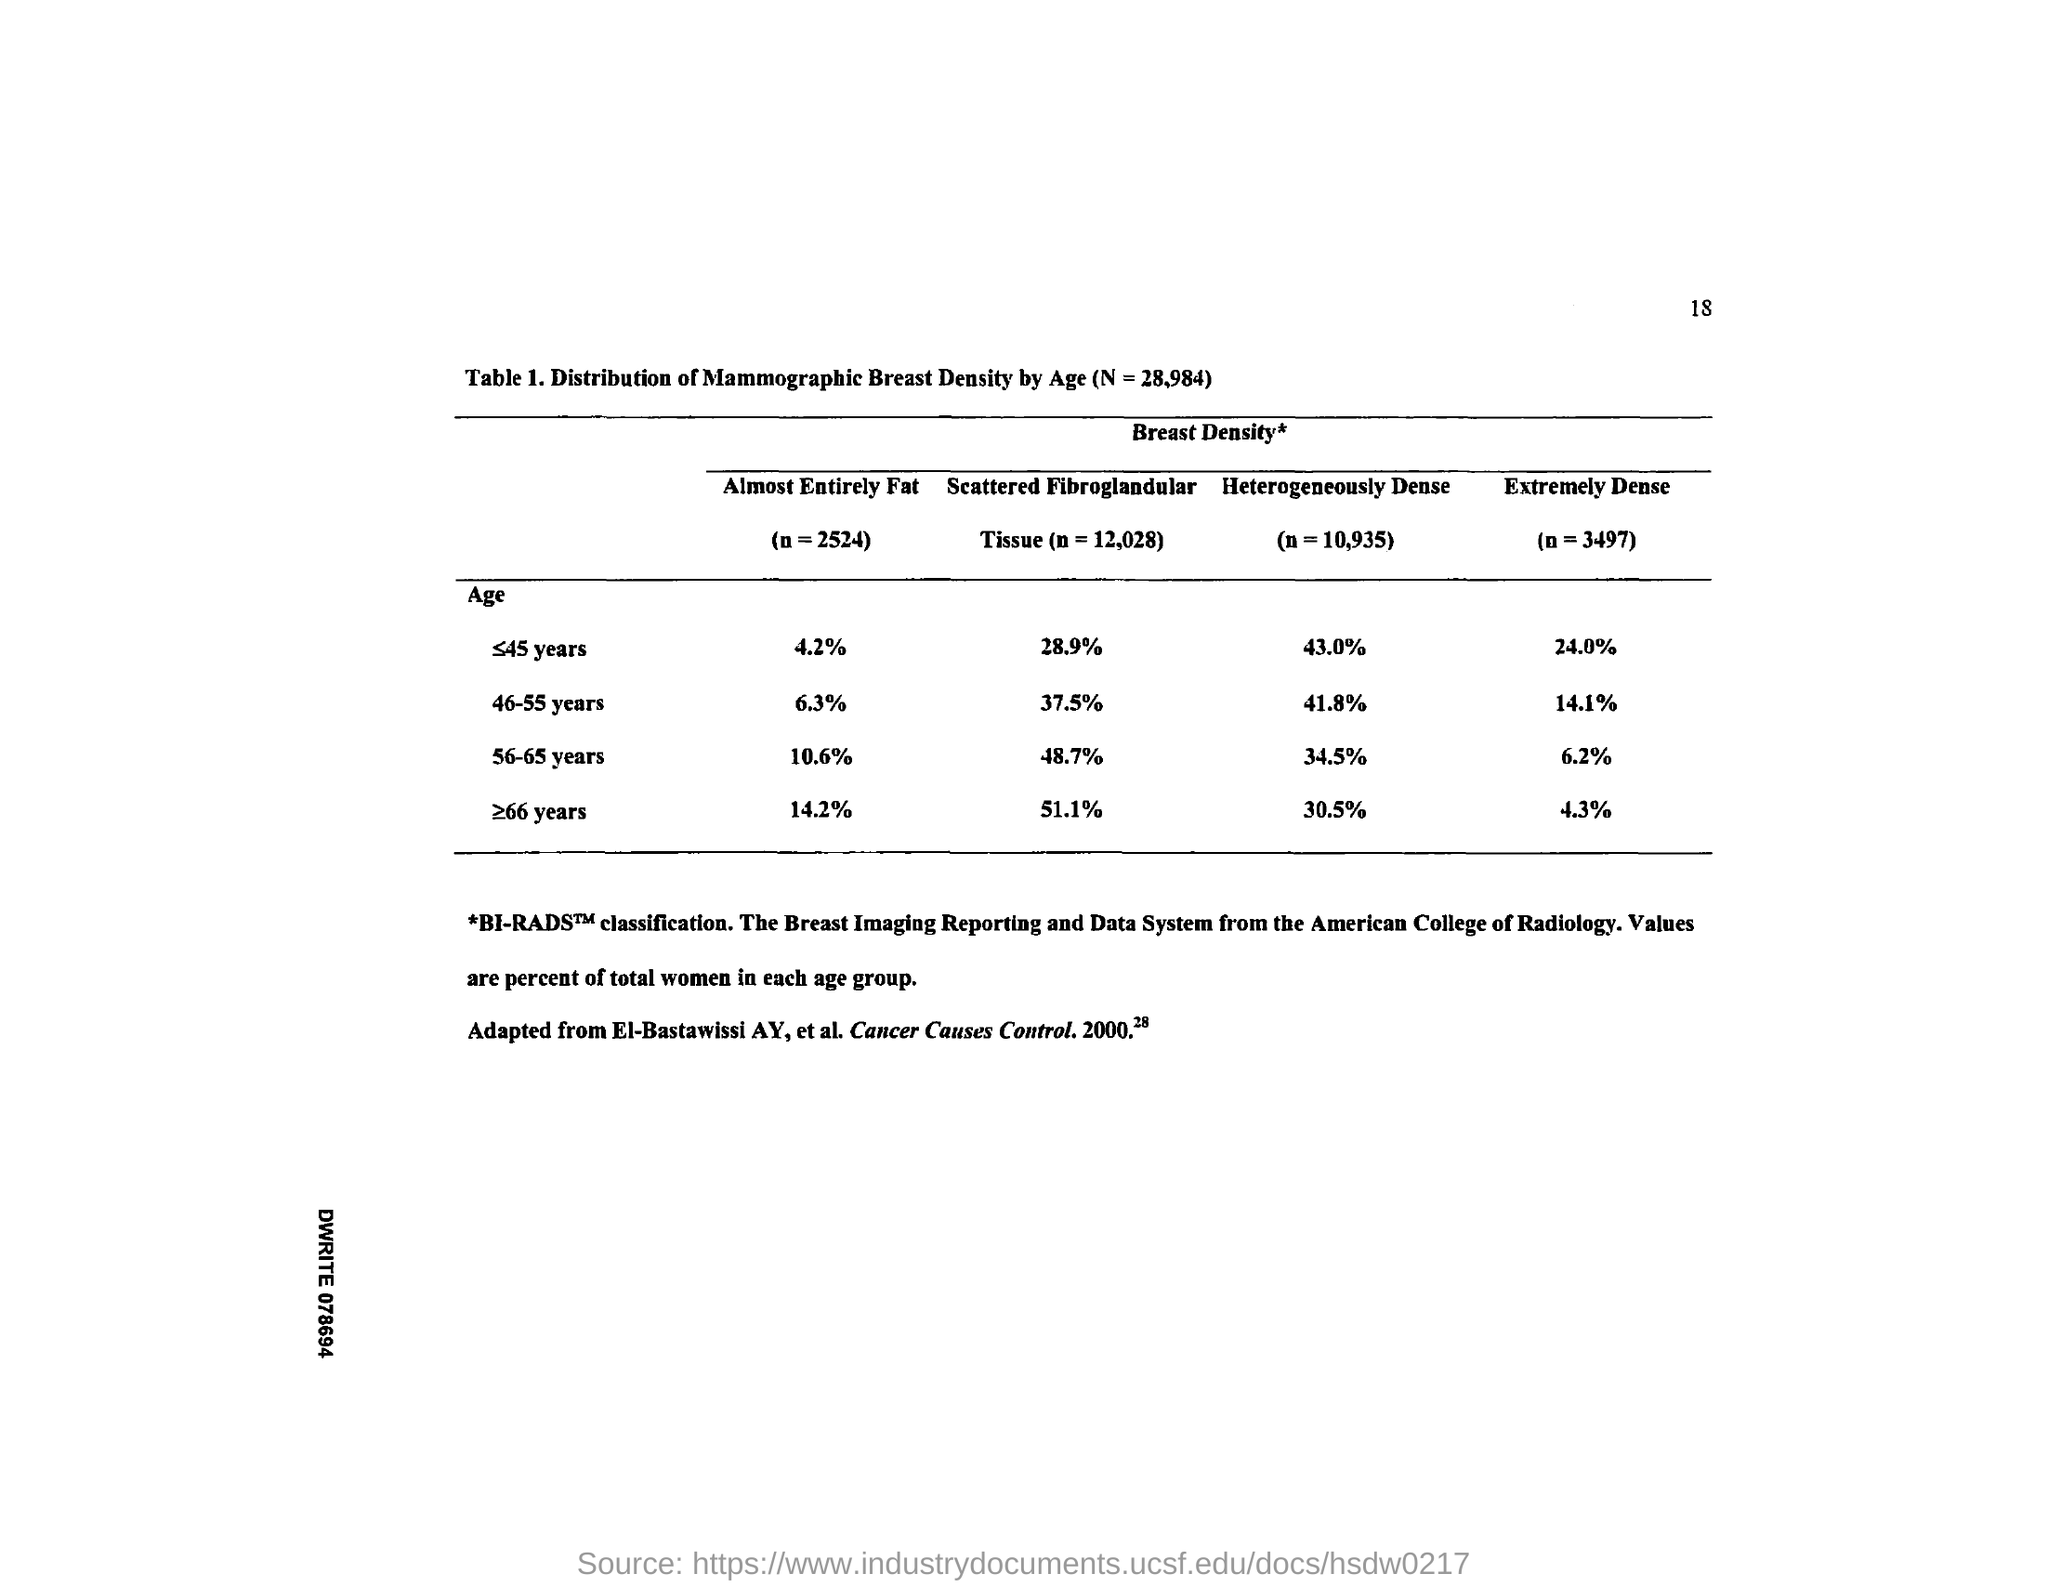What is the value of almost  entirely fat for the age of 46-55 years ?
Offer a very short reply. 6.3%. What is the value of almost  entirely fat for the age of 56-65 years ?
Your answer should be very brief. 10.6 %. What is the value of scattered fibroglandular for the age of 46-55 years ?
Your response must be concise. 37.5%. What is the value of scattered fibroglandular for the age of 56-65 years ?
Provide a short and direct response. 48.7%. What is the value of heterogeneously dense for the age of 46-55 years ?
Your answer should be very brief. 41.8%. What is the value of heterogeneously dense for the age of 56-65 years ?
Offer a terse response. 34.5%. 